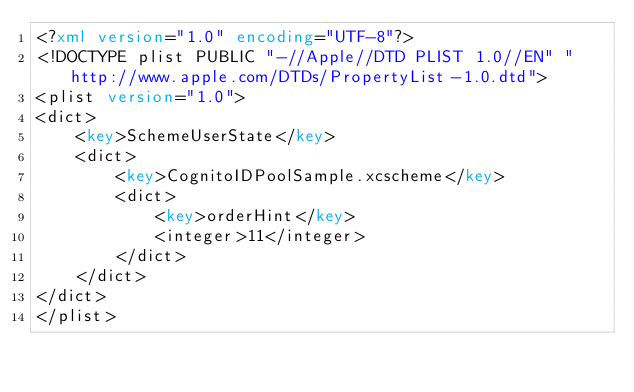<code> <loc_0><loc_0><loc_500><loc_500><_XML_><?xml version="1.0" encoding="UTF-8"?>
<!DOCTYPE plist PUBLIC "-//Apple//DTD PLIST 1.0//EN" "http://www.apple.com/DTDs/PropertyList-1.0.dtd">
<plist version="1.0">
<dict>
	<key>SchemeUserState</key>
	<dict>
		<key>CognitoIDPoolSample.xcscheme</key>
		<dict>
			<key>orderHint</key>
			<integer>11</integer>
		</dict>
	</dict>
</dict>
</plist>
</code> 